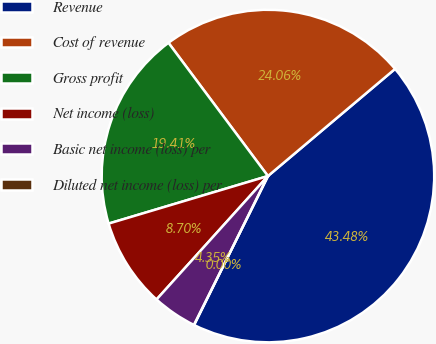Convert chart to OTSL. <chart><loc_0><loc_0><loc_500><loc_500><pie_chart><fcel>Revenue<fcel>Cost of revenue<fcel>Gross profit<fcel>Net income (loss)<fcel>Basic net income (loss) per<fcel>Diluted net income (loss) per<nl><fcel>43.48%<fcel>24.06%<fcel>19.41%<fcel>8.7%<fcel>4.35%<fcel>0.0%<nl></chart> 